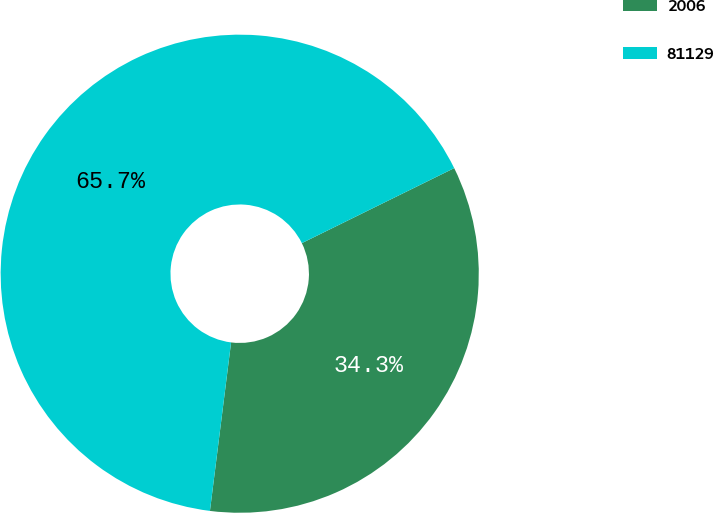Convert chart to OTSL. <chart><loc_0><loc_0><loc_500><loc_500><pie_chart><fcel>2006<fcel>81129<nl><fcel>34.27%<fcel>65.73%<nl></chart> 